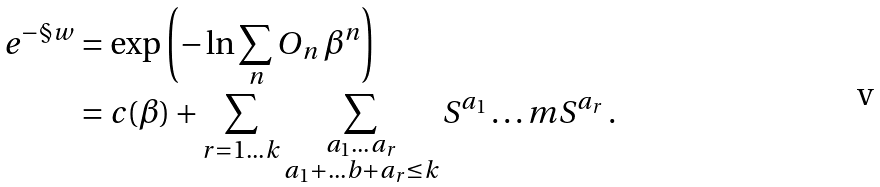<formula> <loc_0><loc_0><loc_500><loc_500>e ^ { - \S w } & = \exp \left ( - \ln \sum _ { n } O _ { n } \, \beta ^ { n } \right ) \\ & = c ( \beta ) + \sum _ { r = 1 \dots k } \sum _ { \substack { a _ { 1 } \dots a _ { r } \\ a _ { 1 } + \dots b + a _ { r } \leq k } } S ^ { a _ { 1 } } \dots m S ^ { a _ { r } } \, .</formula> 